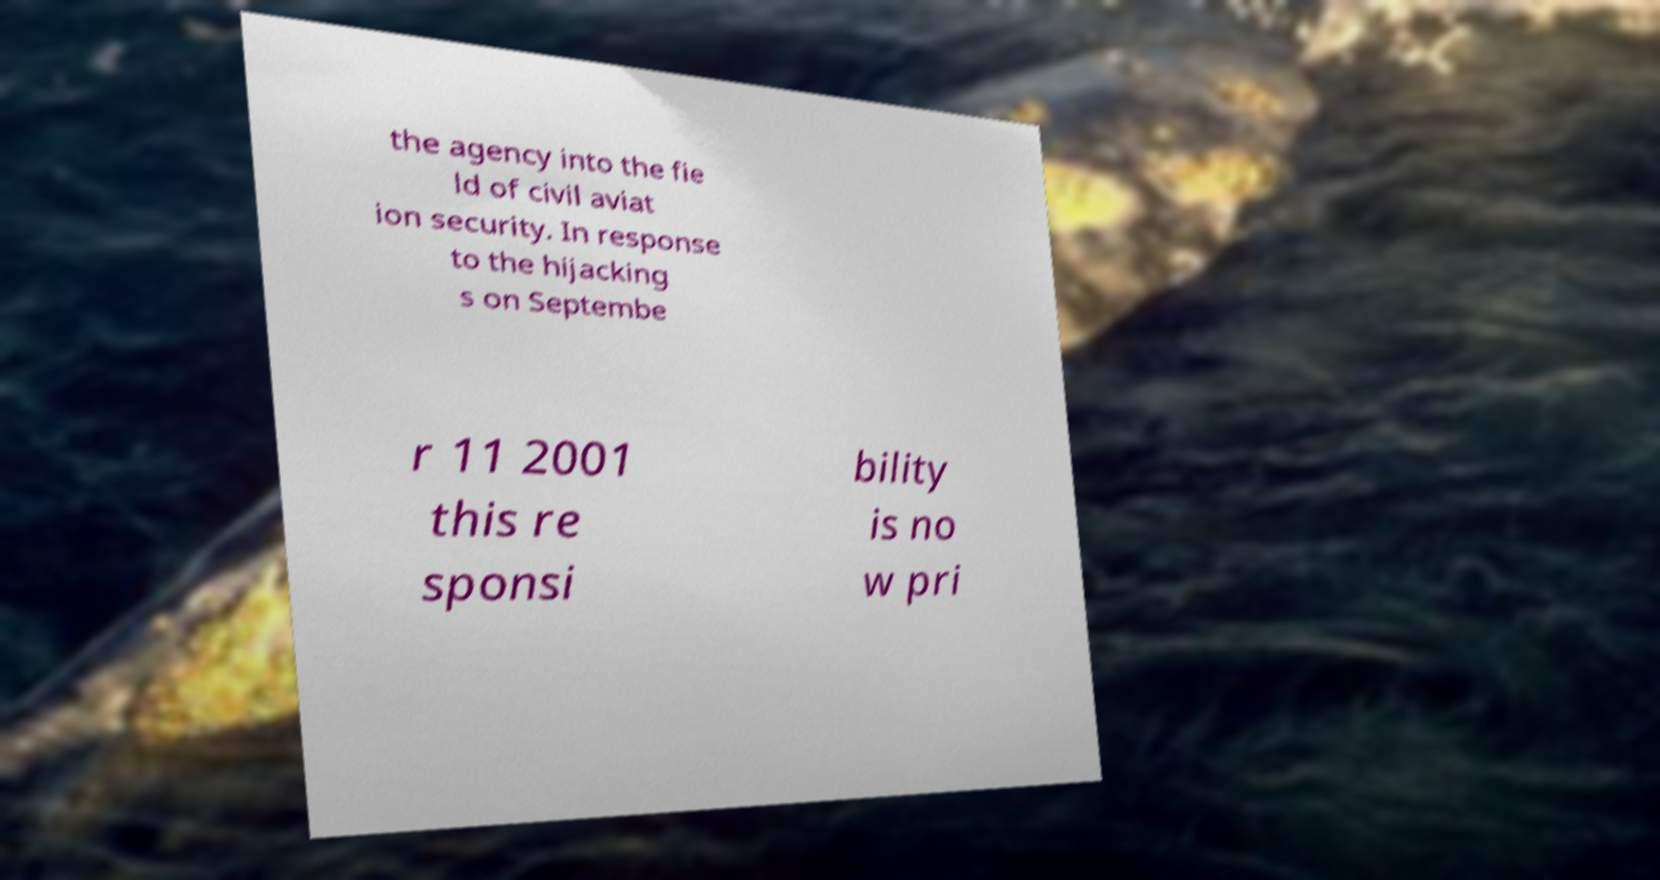Can you read and provide the text displayed in the image?This photo seems to have some interesting text. Can you extract and type it out for me? the agency into the fie ld of civil aviat ion security. In response to the hijacking s on Septembe r 11 2001 this re sponsi bility is no w pri 